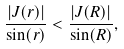Convert formula to latex. <formula><loc_0><loc_0><loc_500><loc_500>\frac { | J ( r ) | } { \sin ( r ) } < \frac { | J ( R ) | } { \sin ( R ) } ,</formula> 